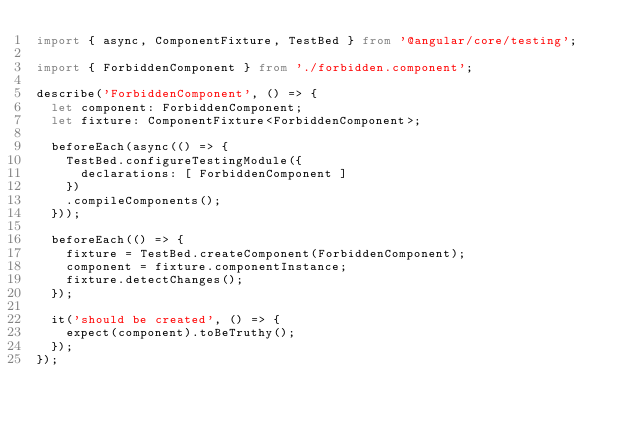<code> <loc_0><loc_0><loc_500><loc_500><_TypeScript_>import { async, ComponentFixture, TestBed } from '@angular/core/testing';

import { ForbiddenComponent } from './forbidden.component';

describe('ForbiddenComponent', () => {
  let component: ForbiddenComponent;
  let fixture: ComponentFixture<ForbiddenComponent>;

  beforeEach(async(() => {
    TestBed.configureTestingModule({
      declarations: [ ForbiddenComponent ]
    })
    .compileComponents();
  }));

  beforeEach(() => {
    fixture = TestBed.createComponent(ForbiddenComponent);
    component = fixture.componentInstance;
    fixture.detectChanges();
  });

  it('should be created', () => {
    expect(component).toBeTruthy();
  });
});
</code> 